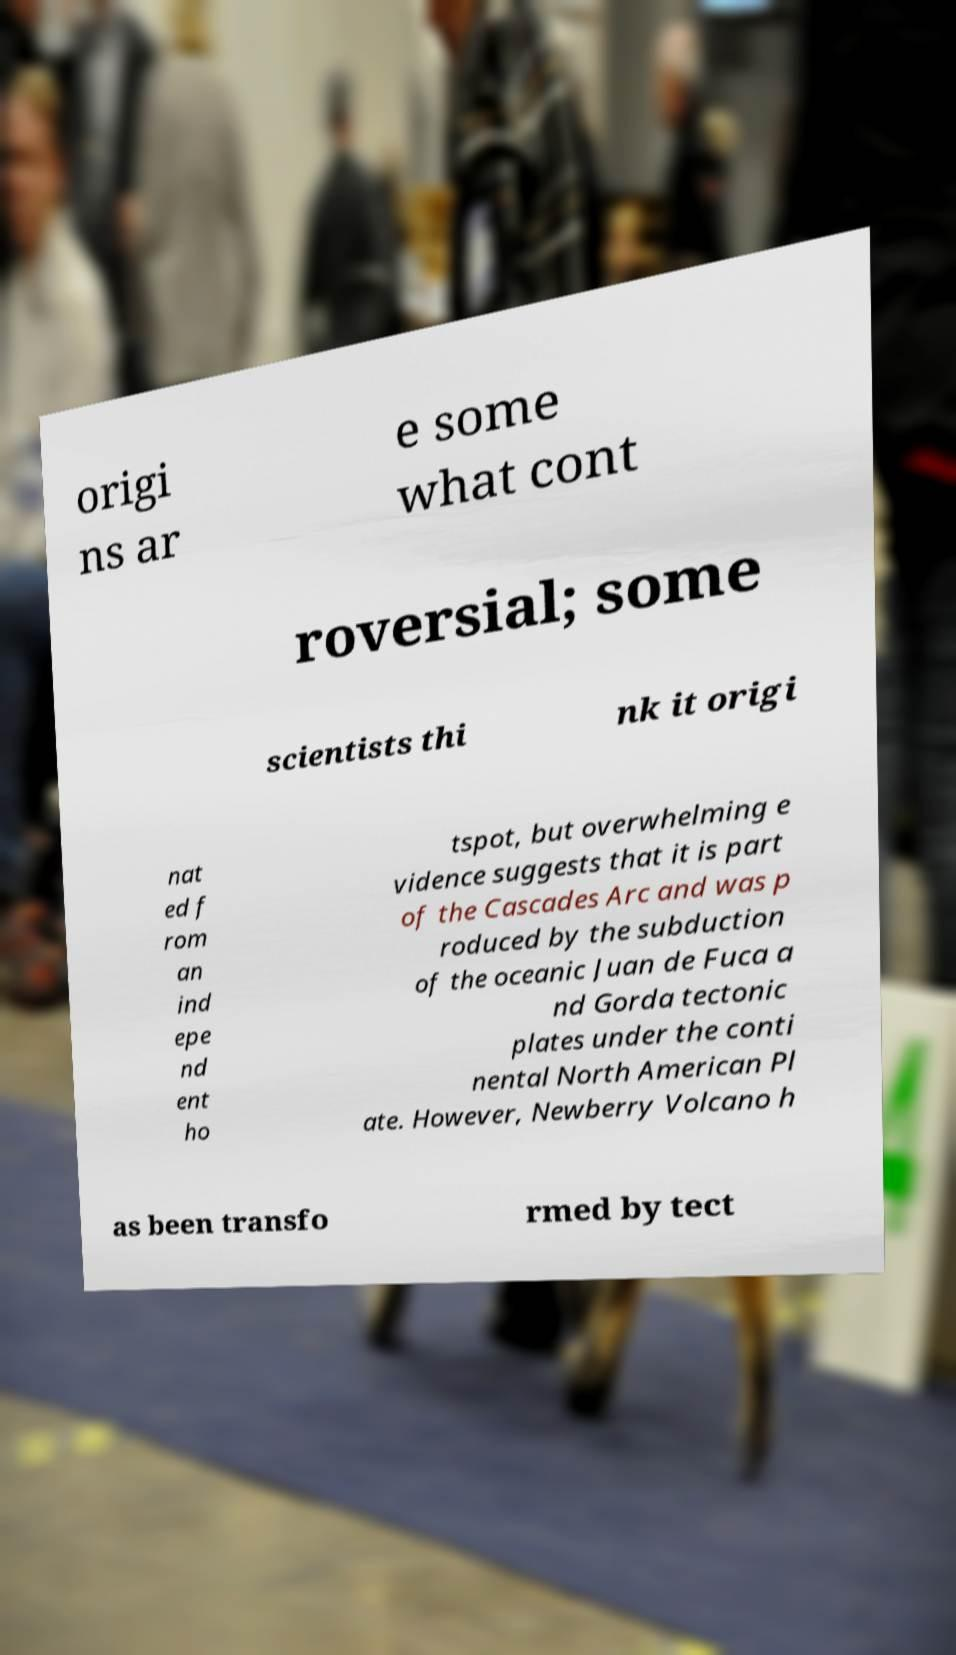Could you extract and type out the text from this image? origi ns ar e some what cont roversial; some scientists thi nk it origi nat ed f rom an ind epe nd ent ho tspot, but overwhelming e vidence suggests that it is part of the Cascades Arc and was p roduced by the subduction of the oceanic Juan de Fuca a nd Gorda tectonic plates under the conti nental North American Pl ate. However, Newberry Volcano h as been transfo rmed by tect 